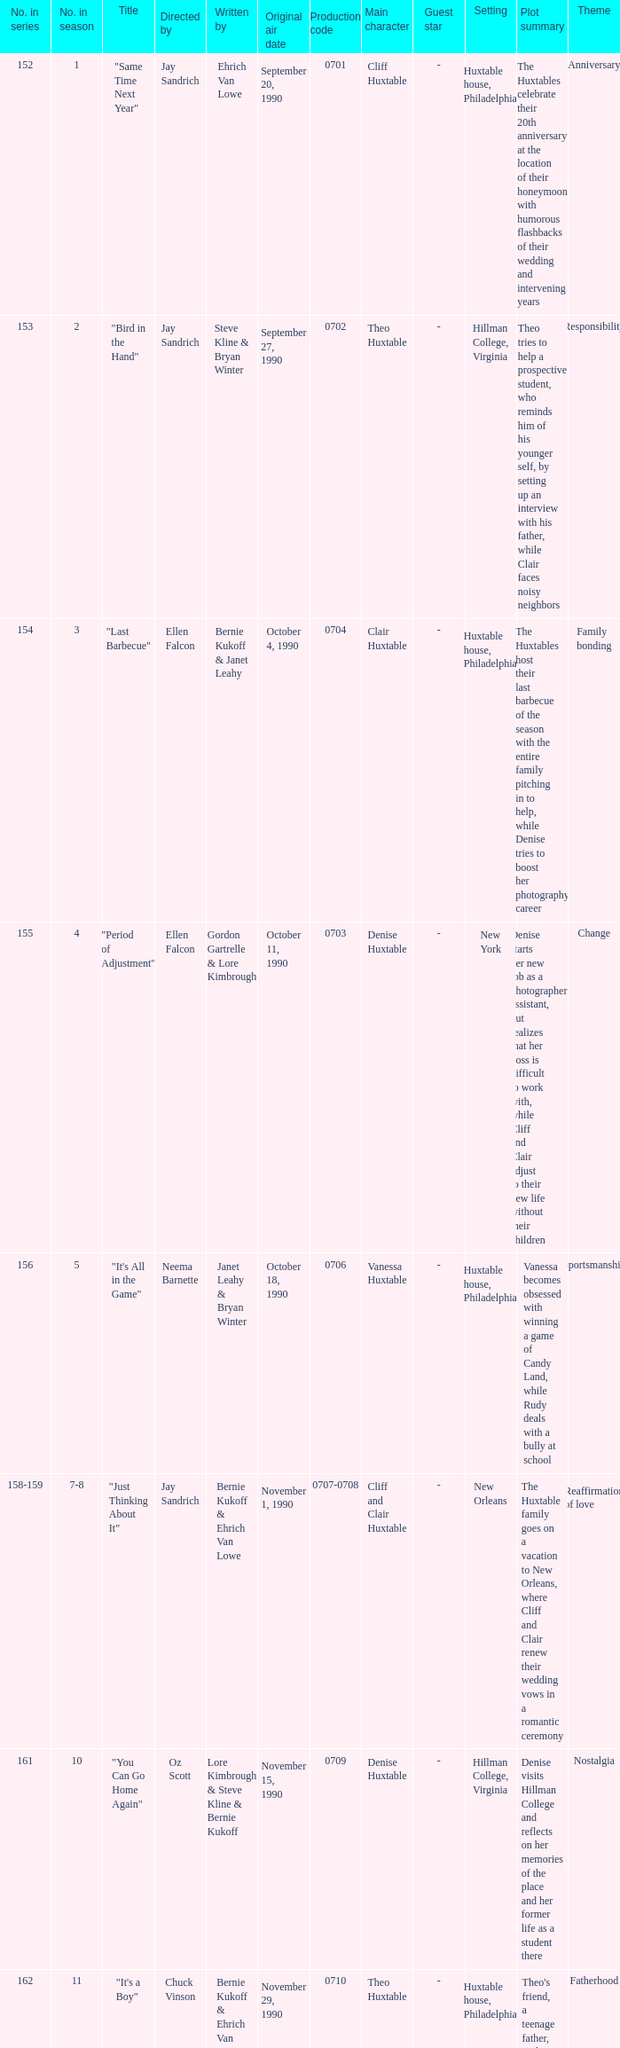The episode directed by art dielhenn was what number in the series?  166.0. 